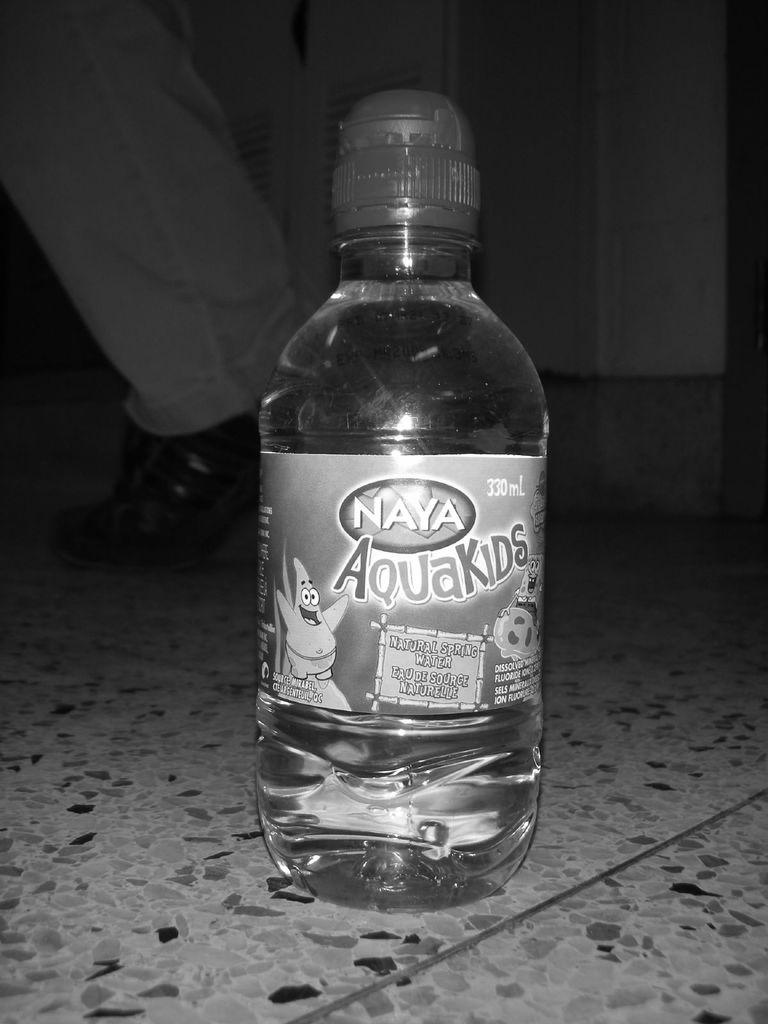<image>
Create a compact narrative representing the image presented. A bottle of Naya Aquakids sits on the floor. 